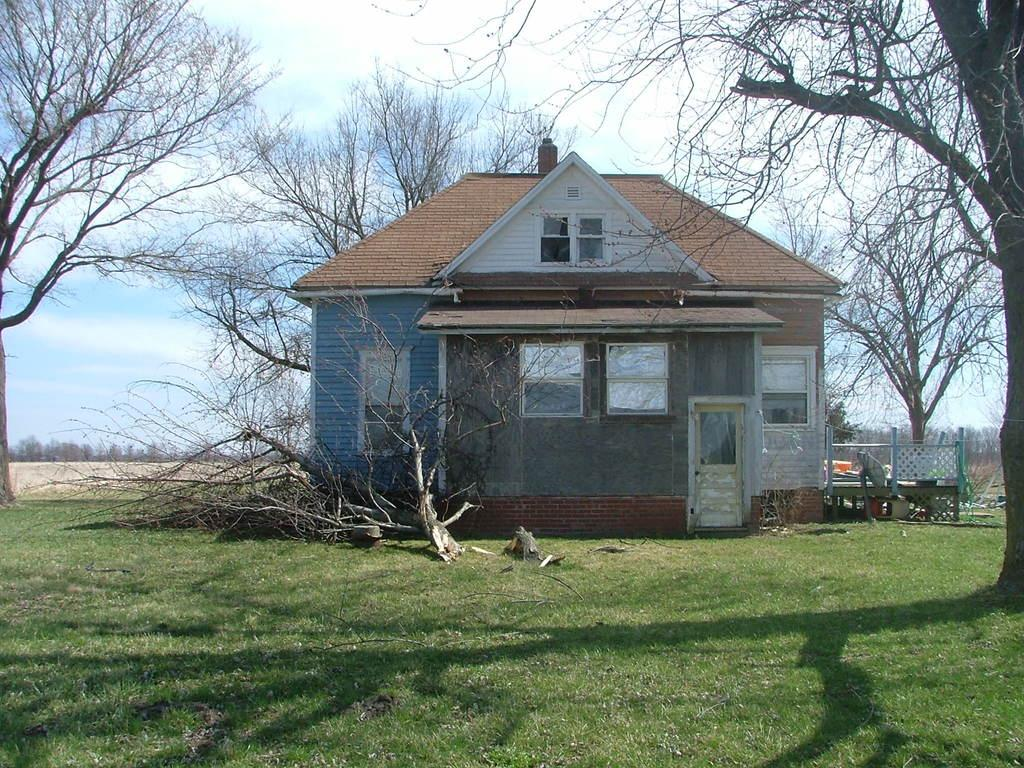What type of structure is visible in the image? There is a house in the image. What type of vegetation can be seen in the image? There is grass and trees in the image. What is visible in the background of the image? The sky is visible in the background of the image. What type of joke is the squirrel telling in the image? There is no squirrel present in the image, and therefore no joke can be observed. What color is the coat worn by the person in the image? There are no people or coats present in the image. 